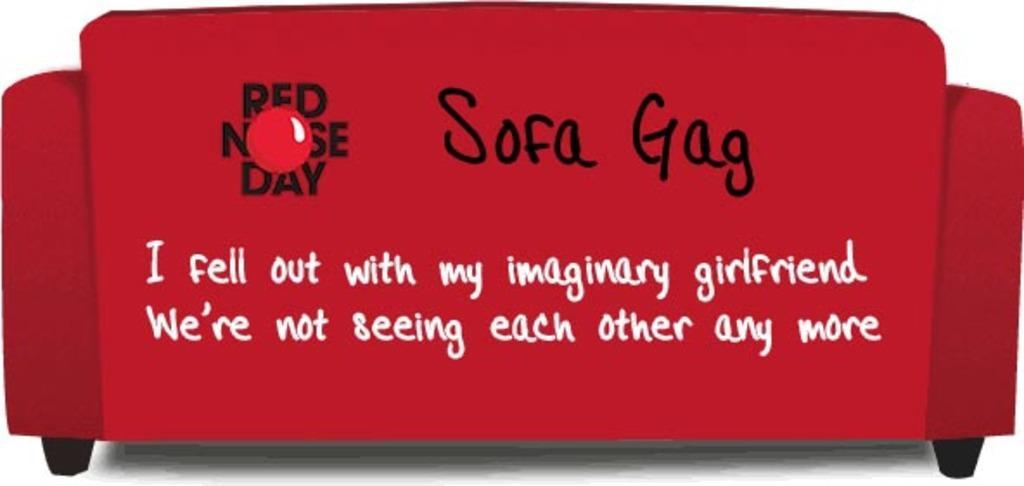Please provide a concise description of this image. In this image we can see an animated red color sofa with some text written on it. 